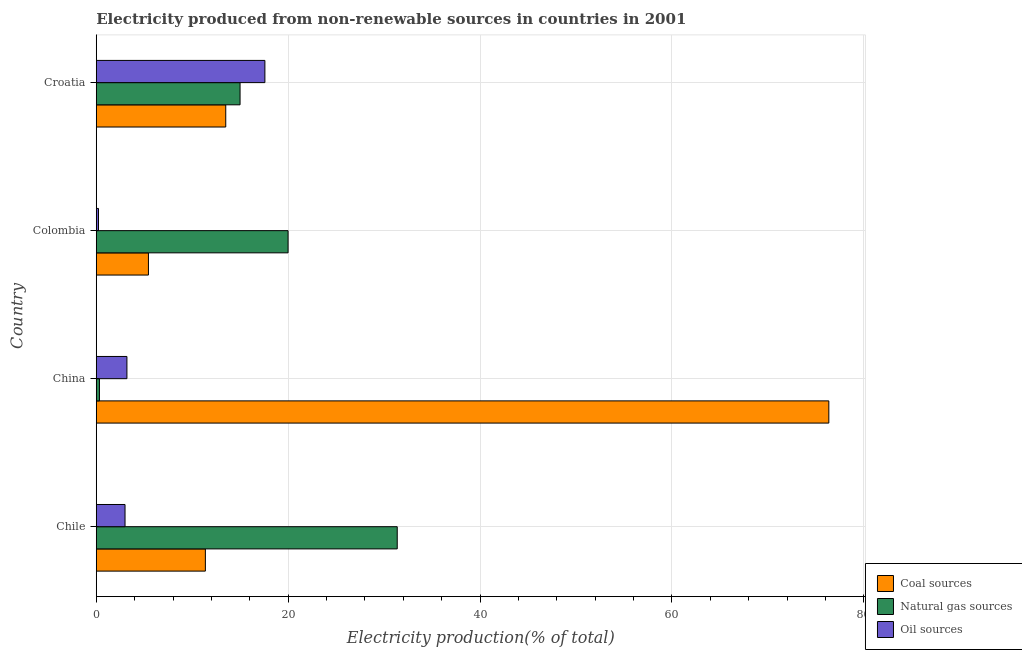How many groups of bars are there?
Ensure brevity in your answer.  4. Are the number of bars on each tick of the Y-axis equal?
Offer a very short reply. Yes. How many bars are there on the 3rd tick from the top?
Keep it short and to the point. 3. What is the label of the 1st group of bars from the top?
Provide a succinct answer. Croatia. What is the percentage of electricity produced by oil sources in Colombia?
Your answer should be very brief. 0.23. Across all countries, what is the maximum percentage of electricity produced by natural gas?
Your answer should be compact. 31.37. Across all countries, what is the minimum percentage of electricity produced by oil sources?
Make the answer very short. 0.23. In which country was the percentage of electricity produced by coal minimum?
Give a very brief answer. Colombia. What is the total percentage of electricity produced by natural gas in the graph?
Make the answer very short. 66.68. What is the difference between the percentage of electricity produced by natural gas in China and that in Colombia?
Make the answer very short. -19.66. What is the difference between the percentage of electricity produced by coal in China and the percentage of electricity produced by natural gas in Chile?
Your answer should be compact. 44.98. What is the average percentage of electricity produced by coal per country?
Offer a very short reply. 26.66. What is the difference between the percentage of electricity produced by oil sources and percentage of electricity produced by natural gas in Chile?
Your response must be concise. -28.37. What is the ratio of the percentage of electricity produced by coal in Colombia to that in Croatia?
Your response must be concise. 0.4. Is the percentage of electricity produced by oil sources in Chile less than that in Croatia?
Ensure brevity in your answer.  Yes. Is the difference between the percentage of electricity produced by oil sources in China and Croatia greater than the difference between the percentage of electricity produced by natural gas in China and Croatia?
Keep it short and to the point. Yes. What is the difference between the highest and the second highest percentage of electricity produced by coal?
Your answer should be very brief. 62.85. What is the difference between the highest and the lowest percentage of electricity produced by oil sources?
Your answer should be compact. 17.34. In how many countries, is the percentage of electricity produced by coal greater than the average percentage of electricity produced by coal taken over all countries?
Provide a succinct answer. 1. What does the 3rd bar from the top in China represents?
Your response must be concise. Coal sources. What does the 1st bar from the bottom in China represents?
Offer a terse response. Coal sources. Is it the case that in every country, the sum of the percentage of electricity produced by coal and percentage of electricity produced by natural gas is greater than the percentage of electricity produced by oil sources?
Offer a very short reply. Yes. How many bars are there?
Ensure brevity in your answer.  12. How many countries are there in the graph?
Your answer should be very brief. 4. What is the difference between two consecutive major ticks on the X-axis?
Keep it short and to the point. 20. Are the values on the major ticks of X-axis written in scientific E-notation?
Offer a terse response. No. How many legend labels are there?
Your answer should be very brief. 3. What is the title of the graph?
Your answer should be compact. Electricity produced from non-renewable sources in countries in 2001. What is the label or title of the Y-axis?
Give a very brief answer. Country. What is the Electricity production(% of total) of Coal sources in Chile?
Give a very brief answer. 11.37. What is the Electricity production(% of total) in Natural gas sources in Chile?
Make the answer very short. 31.37. What is the Electricity production(% of total) of Oil sources in Chile?
Your answer should be compact. 3. What is the Electricity production(% of total) of Coal sources in China?
Offer a terse response. 76.35. What is the Electricity production(% of total) in Natural gas sources in China?
Offer a terse response. 0.33. What is the Electricity production(% of total) in Oil sources in China?
Your answer should be very brief. 3.2. What is the Electricity production(% of total) of Coal sources in Colombia?
Provide a short and direct response. 5.44. What is the Electricity production(% of total) of Natural gas sources in Colombia?
Keep it short and to the point. 19.99. What is the Electricity production(% of total) in Oil sources in Colombia?
Ensure brevity in your answer.  0.23. What is the Electricity production(% of total) of Coal sources in Croatia?
Provide a succinct answer. 13.5. What is the Electricity production(% of total) in Natural gas sources in Croatia?
Provide a succinct answer. 14.99. What is the Electricity production(% of total) of Oil sources in Croatia?
Provide a short and direct response. 17.57. Across all countries, what is the maximum Electricity production(% of total) of Coal sources?
Your answer should be compact. 76.35. Across all countries, what is the maximum Electricity production(% of total) of Natural gas sources?
Offer a terse response. 31.37. Across all countries, what is the maximum Electricity production(% of total) in Oil sources?
Provide a succinct answer. 17.57. Across all countries, what is the minimum Electricity production(% of total) of Coal sources?
Provide a short and direct response. 5.44. Across all countries, what is the minimum Electricity production(% of total) in Natural gas sources?
Offer a terse response. 0.33. Across all countries, what is the minimum Electricity production(% of total) of Oil sources?
Ensure brevity in your answer.  0.23. What is the total Electricity production(% of total) of Coal sources in the graph?
Give a very brief answer. 106.66. What is the total Electricity production(% of total) of Natural gas sources in the graph?
Offer a terse response. 66.68. What is the total Electricity production(% of total) in Oil sources in the graph?
Give a very brief answer. 24. What is the difference between the Electricity production(% of total) in Coal sources in Chile and that in China?
Provide a succinct answer. -64.98. What is the difference between the Electricity production(% of total) in Natural gas sources in Chile and that in China?
Keep it short and to the point. 31.04. What is the difference between the Electricity production(% of total) of Oil sources in Chile and that in China?
Make the answer very short. -0.2. What is the difference between the Electricity production(% of total) of Coal sources in Chile and that in Colombia?
Make the answer very short. 5.94. What is the difference between the Electricity production(% of total) in Natural gas sources in Chile and that in Colombia?
Your answer should be very brief. 11.38. What is the difference between the Electricity production(% of total) of Oil sources in Chile and that in Colombia?
Keep it short and to the point. 2.77. What is the difference between the Electricity production(% of total) of Coal sources in Chile and that in Croatia?
Make the answer very short. -2.12. What is the difference between the Electricity production(% of total) of Natural gas sources in Chile and that in Croatia?
Make the answer very short. 16.38. What is the difference between the Electricity production(% of total) in Oil sources in Chile and that in Croatia?
Your answer should be very brief. -14.58. What is the difference between the Electricity production(% of total) in Coal sources in China and that in Colombia?
Give a very brief answer. 70.91. What is the difference between the Electricity production(% of total) in Natural gas sources in China and that in Colombia?
Make the answer very short. -19.66. What is the difference between the Electricity production(% of total) of Oil sources in China and that in Colombia?
Keep it short and to the point. 2.96. What is the difference between the Electricity production(% of total) in Coal sources in China and that in Croatia?
Keep it short and to the point. 62.85. What is the difference between the Electricity production(% of total) in Natural gas sources in China and that in Croatia?
Your answer should be compact. -14.66. What is the difference between the Electricity production(% of total) in Oil sources in China and that in Croatia?
Ensure brevity in your answer.  -14.38. What is the difference between the Electricity production(% of total) of Coal sources in Colombia and that in Croatia?
Keep it short and to the point. -8.06. What is the difference between the Electricity production(% of total) of Natural gas sources in Colombia and that in Croatia?
Provide a succinct answer. 5. What is the difference between the Electricity production(% of total) in Oil sources in Colombia and that in Croatia?
Provide a short and direct response. -17.34. What is the difference between the Electricity production(% of total) of Coal sources in Chile and the Electricity production(% of total) of Natural gas sources in China?
Make the answer very short. 11.04. What is the difference between the Electricity production(% of total) in Coal sources in Chile and the Electricity production(% of total) in Oil sources in China?
Your answer should be very brief. 8.18. What is the difference between the Electricity production(% of total) in Natural gas sources in Chile and the Electricity production(% of total) in Oil sources in China?
Your response must be concise. 28.17. What is the difference between the Electricity production(% of total) in Coal sources in Chile and the Electricity production(% of total) in Natural gas sources in Colombia?
Make the answer very short. -8.62. What is the difference between the Electricity production(% of total) in Coal sources in Chile and the Electricity production(% of total) in Oil sources in Colombia?
Keep it short and to the point. 11.14. What is the difference between the Electricity production(% of total) in Natural gas sources in Chile and the Electricity production(% of total) in Oil sources in Colombia?
Provide a succinct answer. 31.14. What is the difference between the Electricity production(% of total) of Coal sources in Chile and the Electricity production(% of total) of Natural gas sources in Croatia?
Provide a short and direct response. -3.61. What is the difference between the Electricity production(% of total) in Coal sources in Chile and the Electricity production(% of total) in Oil sources in Croatia?
Your response must be concise. -6.2. What is the difference between the Electricity production(% of total) of Natural gas sources in Chile and the Electricity production(% of total) of Oil sources in Croatia?
Make the answer very short. 13.79. What is the difference between the Electricity production(% of total) in Coal sources in China and the Electricity production(% of total) in Natural gas sources in Colombia?
Provide a succinct answer. 56.36. What is the difference between the Electricity production(% of total) in Coal sources in China and the Electricity production(% of total) in Oil sources in Colombia?
Ensure brevity in your answer.  76.12. What is the difference between the Electricity production(% of total) of Natural gas sources in China and the Electricity production(% of total) of Oil sources in Colombia?
Your answer should be very brief. 0.1. What is the difference between the Electricity production(% of total) in Coal sources in China and the Electricity production(% of total) in Natural gas sources in Croatia?
Offer a very short reply. 61.36. What is the difference between the Electricity production(% of total) in Coal sources in China and the Electricity production(% of total) in Oil sources in Croatia?
Ensure brevity in your answer.  58.78. What is the difference between the Electricity production(% of total) of Natural gas sources in China and the Electricity production(% of total) of Oil sources in Croatia?
Your response must be concise. -17.24. What is the difference between the Electricity production(% of total) in Coal sources in Colombia and the Electricity production(% of total) in Natural gas sources in Croatia?
Your response must be concise. -9.55. What is the difference between the Electricity production(% of total) in Coal sources in Colombia and the Electricity production(% of total) in Oil sources in Croatia?
Offer a very short reply. -12.14. What is the difference between the Electricity production(% of total) in Natural gas sources in Colombia and the Electricity production(% of total) in Oil sources in Croatia?
Make the answer very short. 2.42. What is the average Electricity production(% of total) in Coal sources per country?
Make the answer very short. 26.66. What is the average Electricity production(% of total) in Natural gas sources per country?
Your response must be concise. 16.67. What is the average Electricity production(% of total) in Oil sources per country?
Keep it short and to the point. 6. What is the difference between the Electricity production(% of total) in Coal sources and Electricity production(% of total) in Natural gas sources in Chile?
Keep it short and to the point. -19.99. What is the difference between the Electricity production(% of total) in Coal sources and Electricity production(% of total) in Oil sources in Chile?
Your answer should be compact. 8.38. What is the difference between the Electricity production(% of total) of Natural gas sources and Electricity production(% of total) of Oil sources in Chile?
Provide a short and direct response. 28.37. What is the difference between the Electricity production(% of total) of Coal sources and Electricity production(% of total) of Natural gas sources in China?
Provide a succinct answer. 76.02. What is the difference between the Electricity production(% of total) in Coal sources and Electricity production(% of total) in Oil sources in China?
Keep it short and to the point. 73.16. What is the difference between the Electricity production(% of total) in Natural gas sources and Electricity production(% of total) in Oil sources in China?
Make the answer very short. -2.86. What is the difference between the Electricity production(% of total) of Coal sources and Electricity production(% of total) of Natural gas sources in Colombia?
Give a very brief answer. -14.55. What is the difference between the Electricity production(% of total) of Coal sources and Electricity production(% of total) of Oil sources in Colombia?
Your response must be concise. 5.2. What is the difference between the Electricity production(% of total) of Natural gas sources and Electricity production(% of total) of Oil sources in Colombia?
Your response must be concise. 19.76. What is the difference between the Electricity production(% of total) in Coal sources and Electricity production(% of total) in Natural gas sources in Croatia?
Your answer should be very brief. -1.49. What is the difference between the Electricity production(% of total) of Coal sources and Electricity production(% of total) of Oil sources in Croatia?
Offer a terse response. -4.08. What is the difference between the Electricity production(% of total) of Natural gas sources and Electricity production(% of total) of Oil sources in Croatia?
Your answer should be very brief. -2.59. What is the ratio of the Electricity production(% of total) of Coal sources in Chile to that in China?
Give a very brief answer. 0.15. What is the ratio of the Electricity production(% of total) in Natural gas sources in Chile to that in China?
Ensure brevity in your answer.  94.44. What is the ratio of the Electricity production(% of total) of Oil sources in Chile to that in China?
Ensure brevity in your answer.  0.94. What is the ratio of the Electricity production(% of total) in Coal sources in Chile to that in Colombia?
Make the answer very short. 2.09. What is the ratio of the Electricity production(% of total) in Natural gas sources in Chile to that in Colombia?
Provide a short and direct response. 1.57. What is the ratio of the Electricity production(% of total) in Oil sources in Chile to that in Colombia?
Provide a succinct answer. 12.89. What is the ratio of the Electricity production(% of total) in Coal sources in Chile to that in Croatia?
Provide a succinct answer. 0.84. What is the ratio of the Electricity production(% of total) in Natural gas sources in Chile to that in Croatia?
Keep it short and to the point. 2.09. What is the ratio of the Electricity production(% of total) in Oil sources in Chile to that in Croatia?
Provide a succinct answer. 0.17. What is the ratio of the Electricity production(% of total) in Coal sources in China to that in Colombia?
Your response must be concise. 14.04. What is the ratio of the Electricity production(% of total) in Natural gas sources in China to that in Colombia?
Your answer should be very brief. 0.02. What is the ratio of the Electricity production(% of total) of Oil sources in China to that in Colombia?
Offer a very short reply. 13.74. What is the ratio of the Electricity production(% of total) of Coal sources in China to that in Croatia?
Offer a terse response. 5.66. What is the ratio of the Electricity production(% of total) in Natural gas sources in China to that in Croatia?
Your answer should be very brief. 0.02. What is the ratio of the Electricity production(% of total) in Oil sources in China to that in Croatia?
Your response must be concise. 0.18. What is the ratio of the Electricity production(% of total) of Coal sources in Colombia to that in Croatia?
Your answer should be compact. 0.4. What is the ratio of the Electricity production(% of total) of Natural gas sources in Colombia to that in Croatia?
Your answer should be very brief. 1.33. What is the ratio of the Electricity production(% of total) of Oil sources in Colombia to that in Croatia?
Provide a short and direct response. 0.01. What is the difference between the highest and the second highest Electricity production(% of total) in Coal sources?
Provide a succinct answer. 62.85. What is the difference between the highest and the second highest Electricity production(% of total) of Natural gas sources?
Make the answer very short. 11.38. What is the difference between the highest and the second highest Electricity production(% of total) in Oil sources?
Provide a short and direct response. 14.38. What is the difference between the highest and the lowest Electricity production(% of total) of Coal sources?
Your response must be concise. 70.91. What is the difference between the highest and the lowest Electricity production(% of total) in Natural gas sources?
Your answer should be compact. 31.04. What is the difference between the highest and the lowest Electricity production(% of total) of Oil sources?
Give a very brief answer. 17.34. 